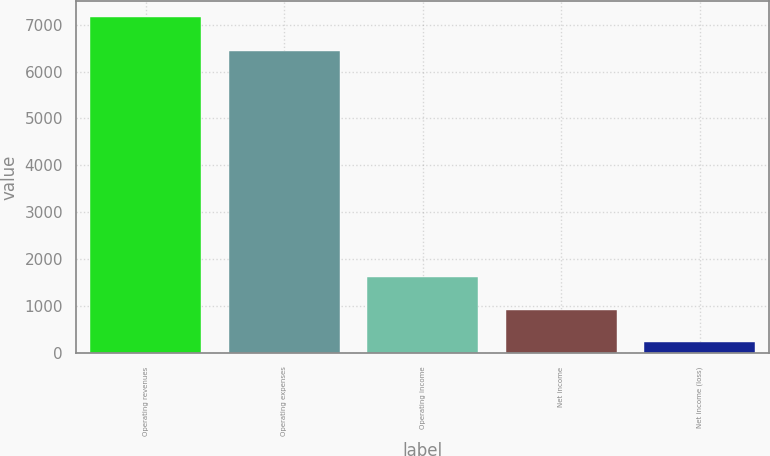Convert chart to OTSL. <chart><loc_0><loc_0><loc_500><loc_500><bar_chart><fcel>Operating revenues<fcel>Operating expenses<fcel>Operating income<fcel>Net income<fcel>Net income (loss)<nl><fcel>7153<fcel>6435<fcel>1613<fcel>920.5<fcel>228<nl></chart> 